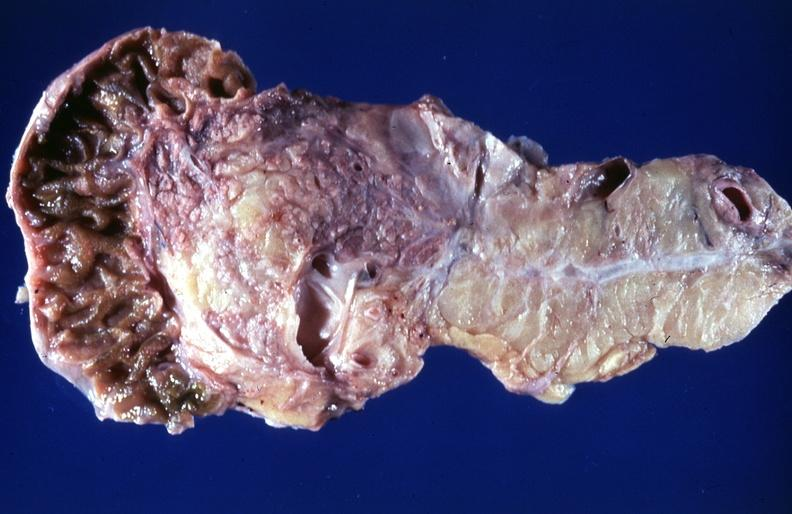s all pelvic organs tumor mass present?
Answer the question using a single word or phrase. No 